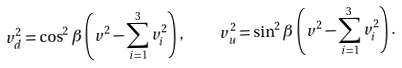Convert formula to latex. <formula><loc_0><loc_0><loc_500><loc_500>v _ { d } ^ { 2 } = \cos ^ { 2 } \beta \left ( v ^ { 2 } - \sum _ { i = 1 } ^ { 3 } v _ { i } ^ { 2 } \right ) , \quad v _ { u } ^ { 2 } = \sin ^ { 2 } \beta \left ( v ^ { 2 } - \sum _ { i = 1 } ^ { 3 } v _ { i } ^ { 2 } \right ) .</formula> 